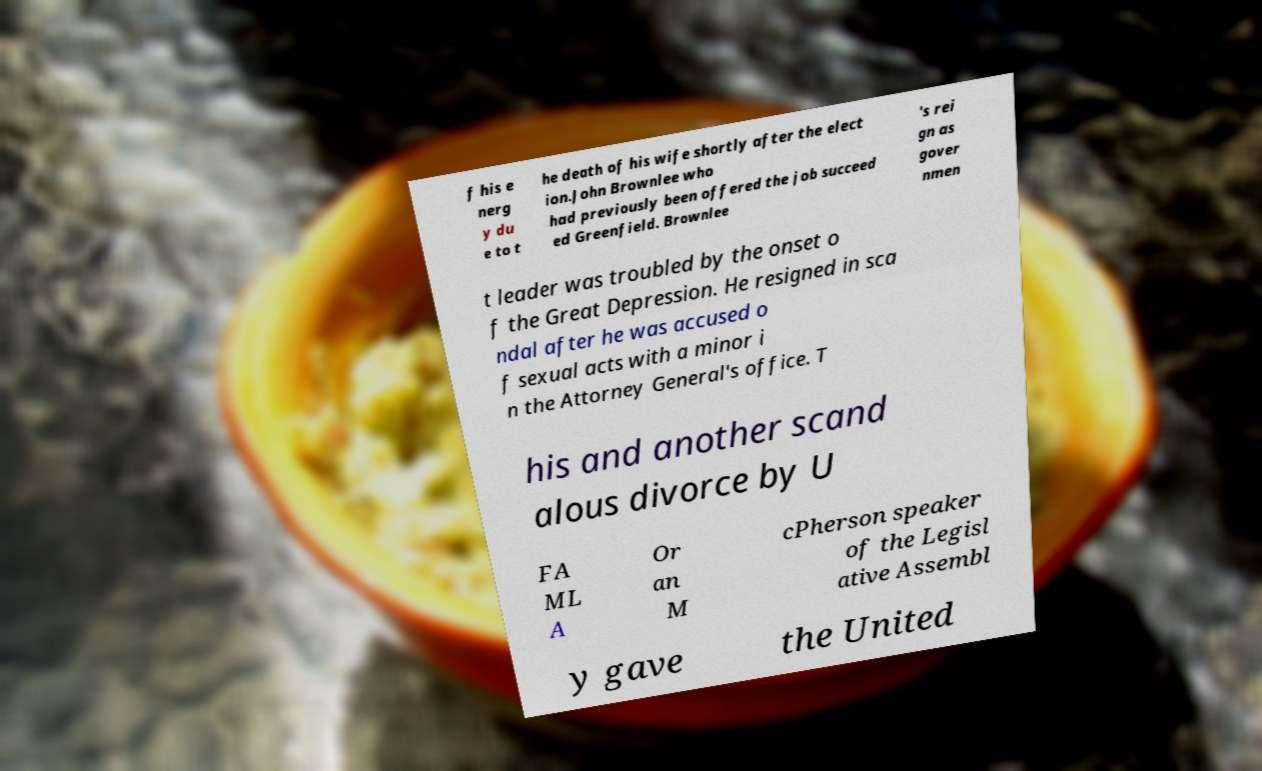Could you extract and type out the text from this image? f his e nerg y du e to t he death of his wife shortly after the elect ion.John Brownlee who had previously been offered the job succeed ed Greenfield. Brownlee 's rei gn as gover nmen t leader was troubled by the onset o f the Great Depression. He resigned in sca ndal after he was accused o f sexual acts with a minor i n the Attorney General's office. T his and another scand alous divorce by U FA ML A Or an M cPherson speaker of the Legisl ative Assembl y gave the United 